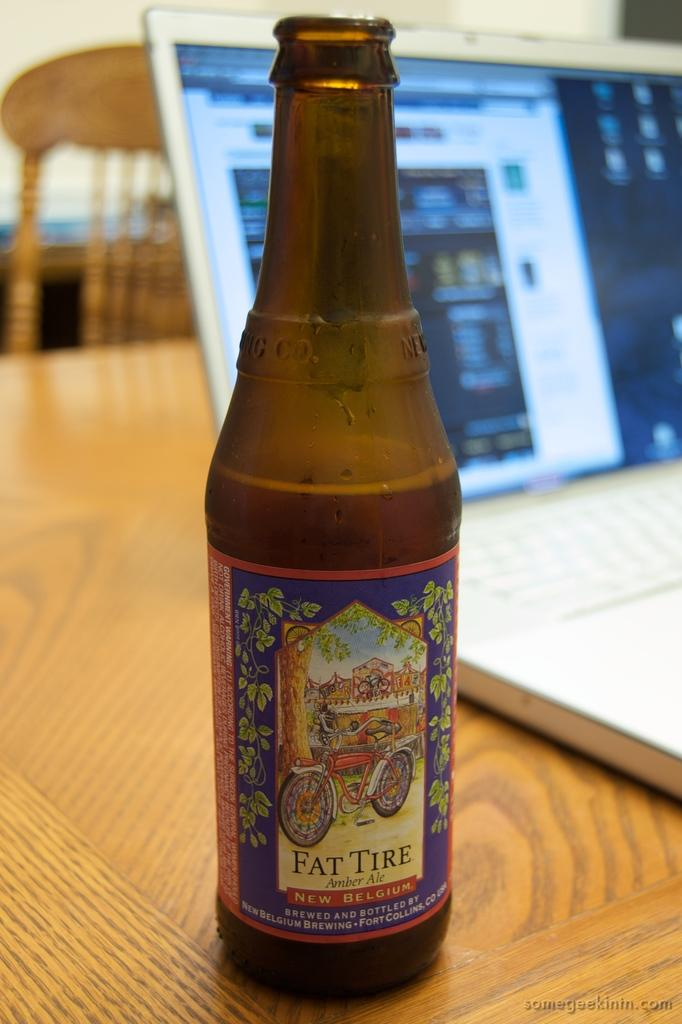What object can be seen in the image that is typically used for holding liquids? There is a bottle in the image. What electronic device is present on the table in the image? There is a laptop on the table in the image. What type of furniture is visible in the image? There is a chair in the image. Can you see a ball being used by an expert in the image? There is no ball or expert present in the image. Can you see a person rubbing the laptop in the image? There is no person or rubbing action involving the laptop in the image. 